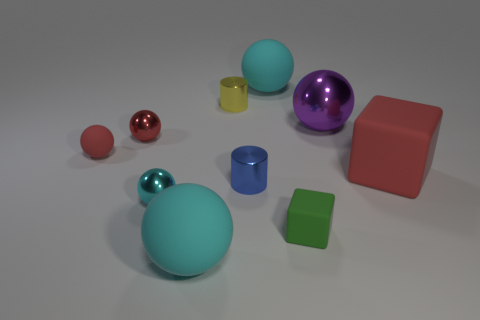There is a yellow shiny cylinder that is behind the purple sphere; is it the same size as the big shiny ball?
Your answer should be compact. No. Is there a thing?
Offer a very short reply. Yes. How many things are either red objects to the right of the tiny cyan sphere or big spheres?
Give a very brief answer. 4. Do the big metal ball and the cylinder behind the large red matte block have the same color?
Give a very brief answer. No. Is there a red matte cube of the same size as the blue metallic cylinder?
Offer a terse response. No. There is a small thing that is to the right of the big cyan rubber sphere that is on the right side of the blue metallic object; what is its material?
Provide a short and direct response. Rubber. How many large rubber cubes are the same color as the tiny rubber ball?
Offer a terse response. 1. There is a red thing that is made of the same material as the red cube; what is its shape?
Make the answer very short. Sphere. There is a cyan matte sphere in front of the red cube; what size is it?
Your response must be concise. Large. Are there the same number of cyan metal spheres in front of the big red object and cyan things that are to the left of the tiny cyan object?
Offer a very short reply. No. 